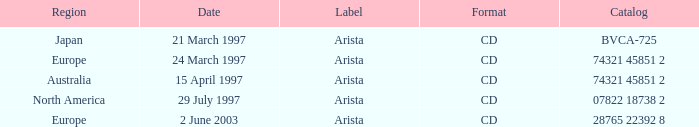What layout is associated with the europe region and a catalog of 74321 45851 2? CD. 